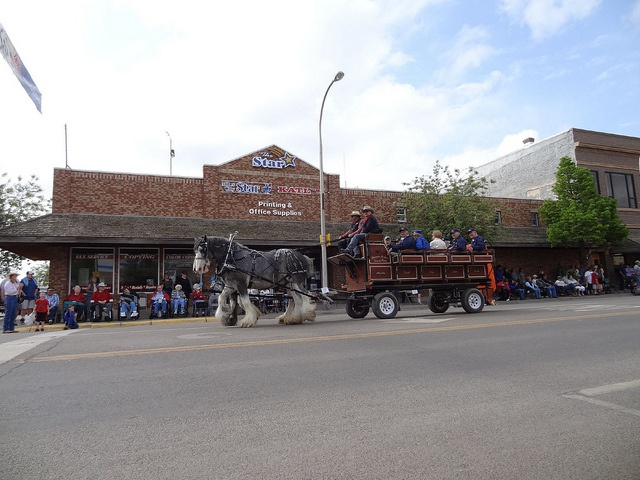Describe the objects in this image and their specific colors. I can see people in white, black, gray, maroon, and navy tones, horse in white, black, gray, and darkgray tones, horse in white, gray, black, and darkgray tones, people in white, navy, black, darkgray, and gray tones, and people in white, black, gray, and maroon tones in this image. 